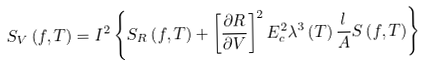Convert formula to latex. <formula><loc_0><loc_0><loc_500><loc_500>S _ { V } \left ( f , T \right ) = I ^ { 2 } \left \{ S _ { R } \left ( f , T \right ) + \left [ \frac { \partial R } { \partial V } \right ] ^ { 2 } E _ { c } ^ { 2 } \lambda ^ { 3 } \left ( T \right ) \frac { l } { A } S \left ( f , T \right ) \right \}</formula> 